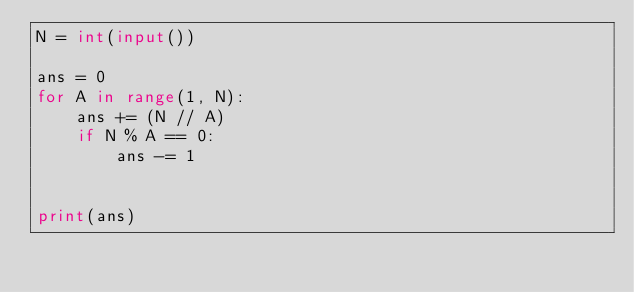<code> <loc_0><loc_0><loc_500><loc_500><_Python_>N = int(input())

ans = 0
for A in range(1, N):
    ans += (N // A)
    if N % A == 0:
        ans -= 1


print(ans)</code> 